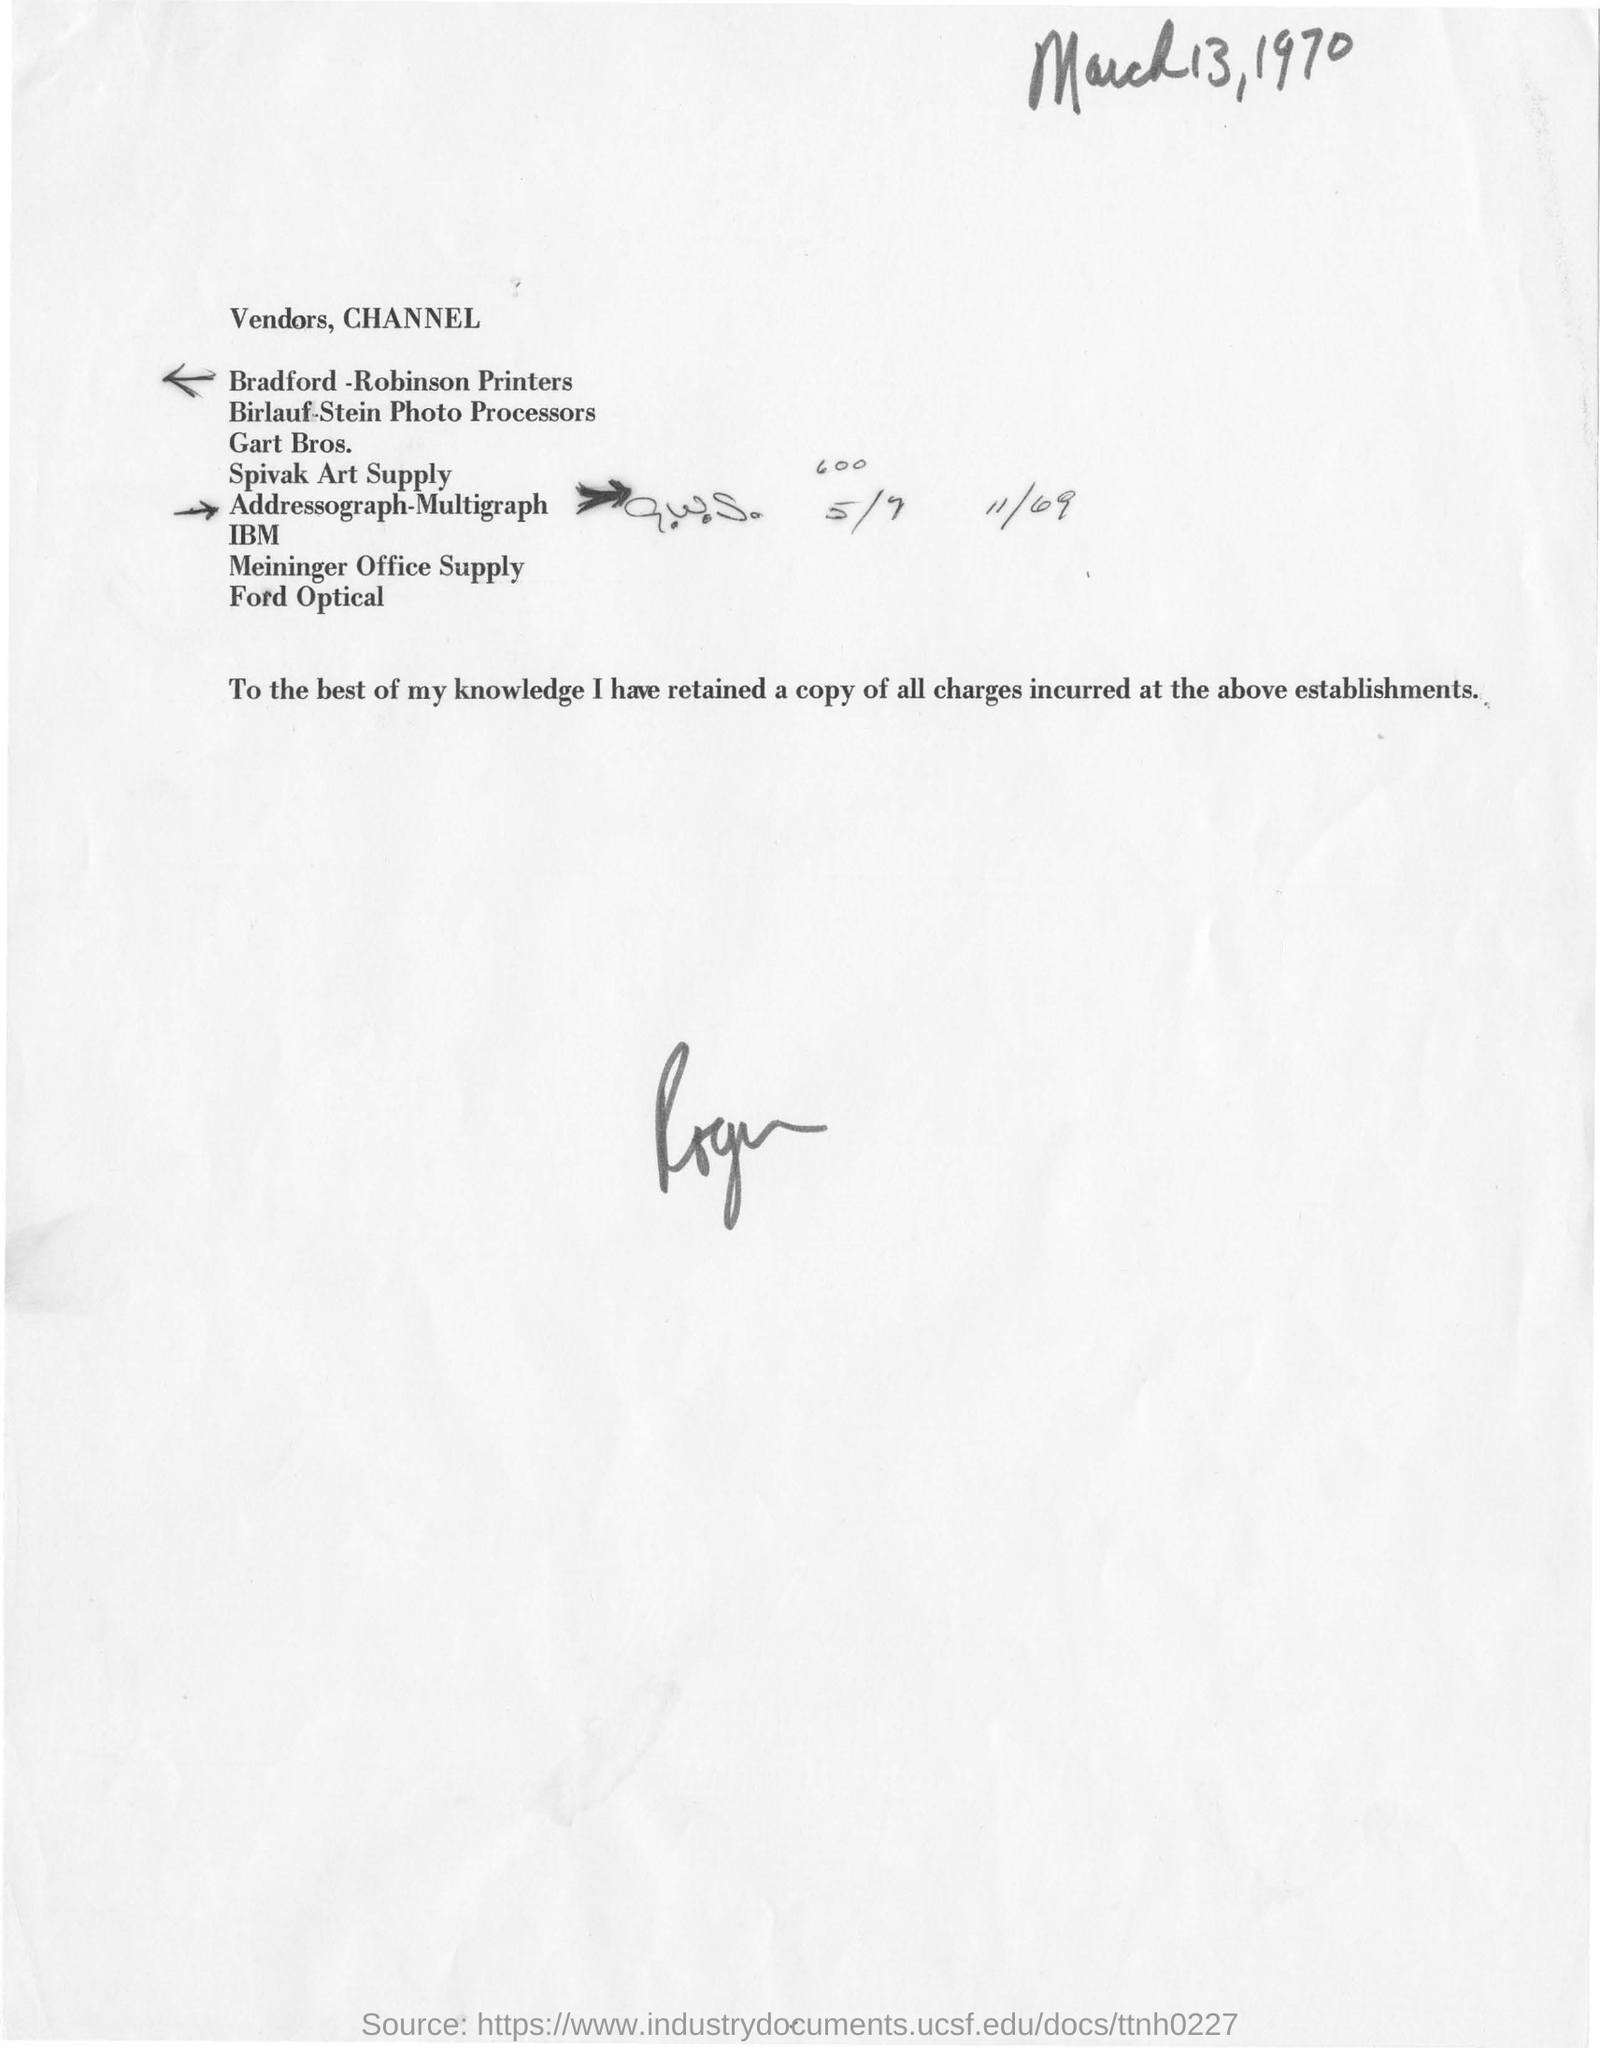Give some essential details in this illustration. The printers mentioned are Bradford -Robinson Printers. The date mentioned in this document is March 13, 1970. 